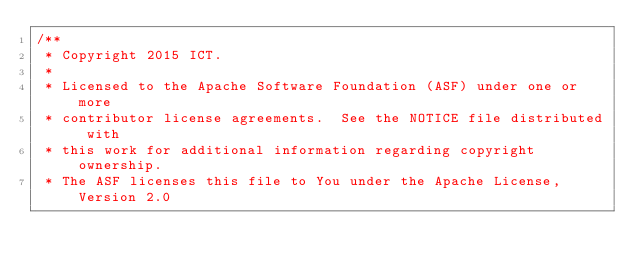Convert code to text. <code><loc_0><loc_0><loc_500><loc_500><_Scala_>/**
 * Copyright 2015 ICT.
 *
 * Licensed to the Apache Software Foundation (ASF) under one or more
 * contributor license agreements.  See the NOTICE file distributed with
 * this work for additional information regarding copyright ownership.
 * The ASF licenses this file to You under the Apache License, Version 2.0</code> 